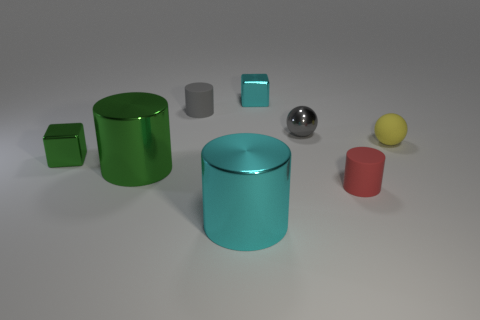Subtract all blue cylinders. Subtract all gray spheres. How many cylinders are left? 4 Add 1 yellow balls. How many objects exist? 9 Subtract all spheres. How many objects are left? 6 Subtract all small things. Subtract all blue objects. How many objects are left? 2 Add 1 small rubber things. How many small rubber things are left? 4 Add 3 rubber cylinders. How many rubber cylinders exist? 5 Subtract 0 brown balls. How many objects are left? 8 